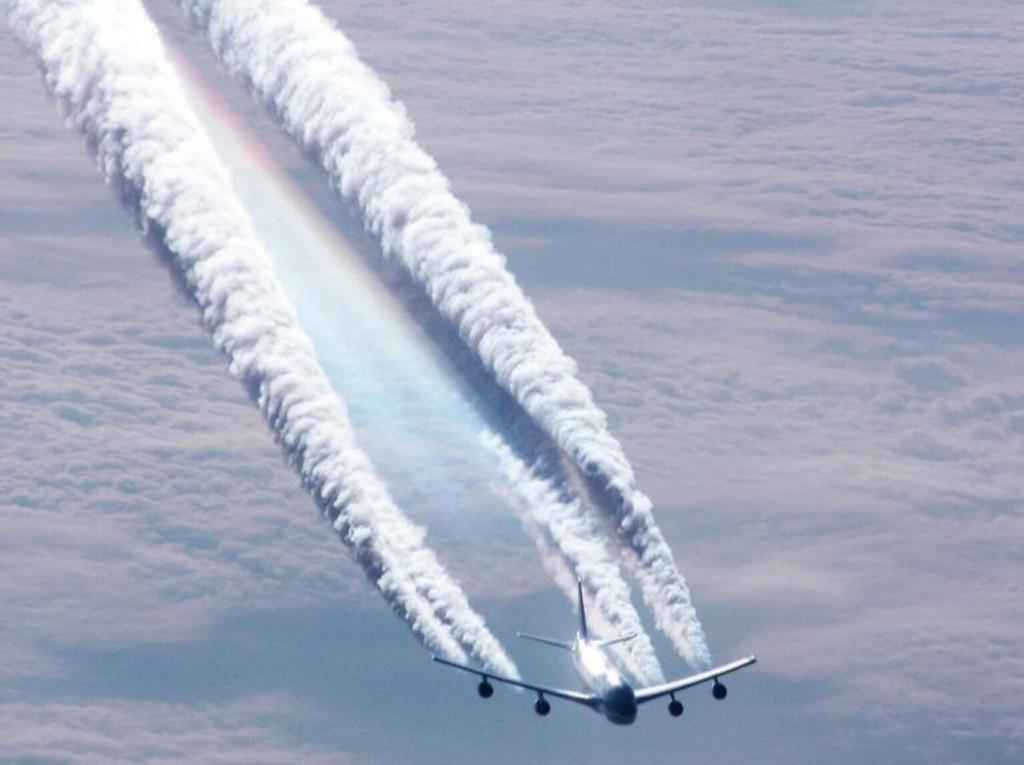What is the main subject of the image? The main subject of the image is an airplane. What is the airplane doing in the image? The airplane is flying in the image. What can be seen in the background of the image? The sky is visible in the background of the image. What is the condition of the sky in the image? Clouds are present in the sky in the image. Can you see a match being lit in the image? There is no match or any indication of a fire in the image. Is there an argument taking place between the passengers in the airplane? The image does not show any passengers or any indication of an argument. 